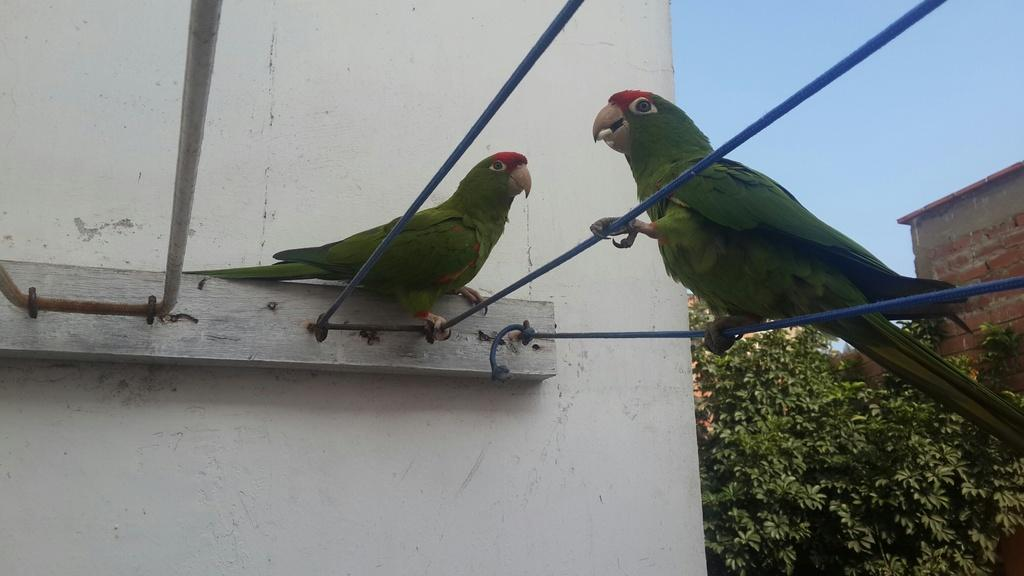What is the condition of the sky in the image? The sky is clear in the image. What type of vegetation is present in the image? There is a plant in the image. What animals can be seen in the image? There are two parrots in the image. What type of structures are visible in the image? There are houses visible in the image. What type of operation is the doctor performing on the parrot in the image? There is no doctor or operation present in the image; it only features a clear sky, a plant, two parrots, and houses. 